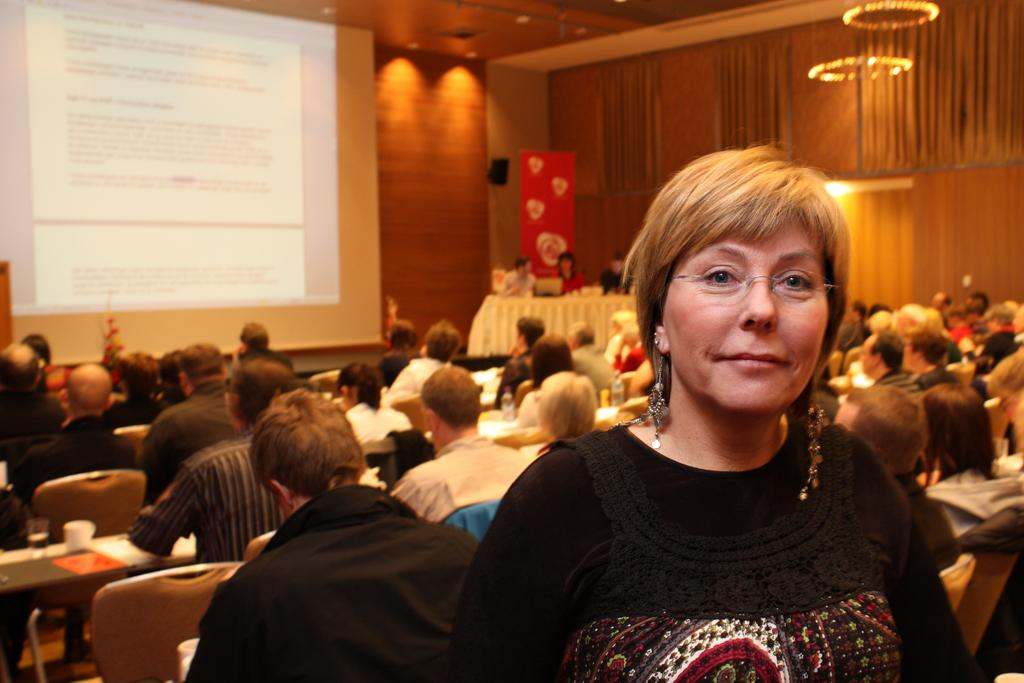What are the people in the image doing? There is a group of persons sitting on a bench in the image. What is in front of the group of persons? There is a screen in front of the group of persons. Can you describe the woman in the image? There is a woman standing in the right corner of the image. What month is it in the image? The month cannot be determined from the image, as there is no information about the time of year. Is there any butter visible in the image? There is no butter present in the image. 